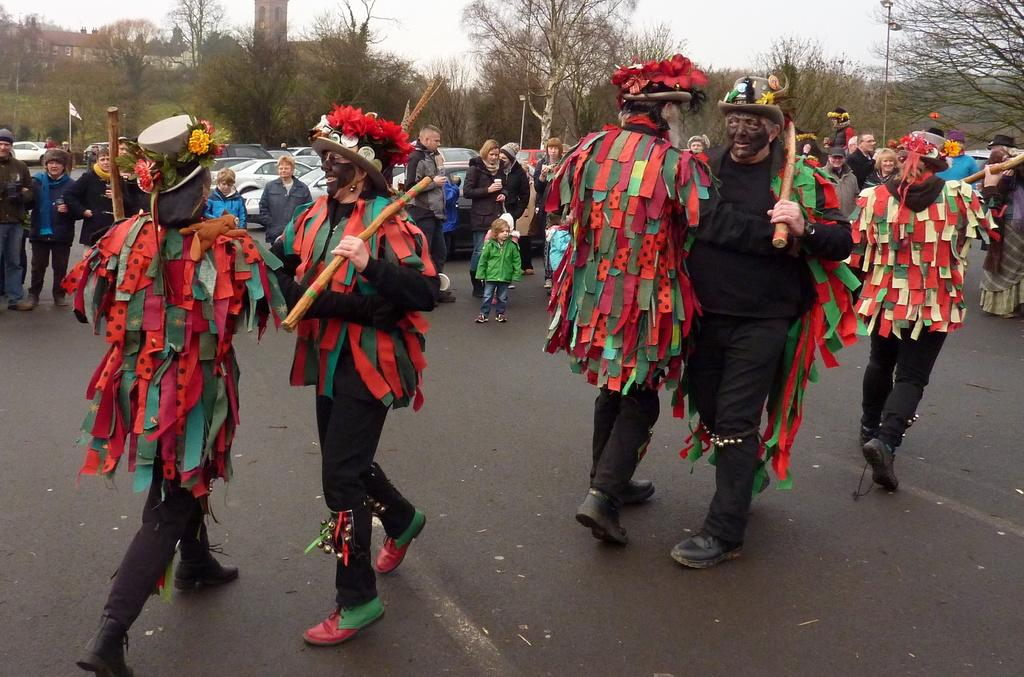What are the people in the image doing? The people in the image are dancing. How are the people dressed while dancing? The people are wearing different dresses. What can be seen in the background of the image? There are groups of people, trees, cars, and a building in the background of the image. What type of creature can be seen climbing the slope in the image? There is no creature or slope present in the image. How many trains are visible in the image? There are no trains visible in the image. 